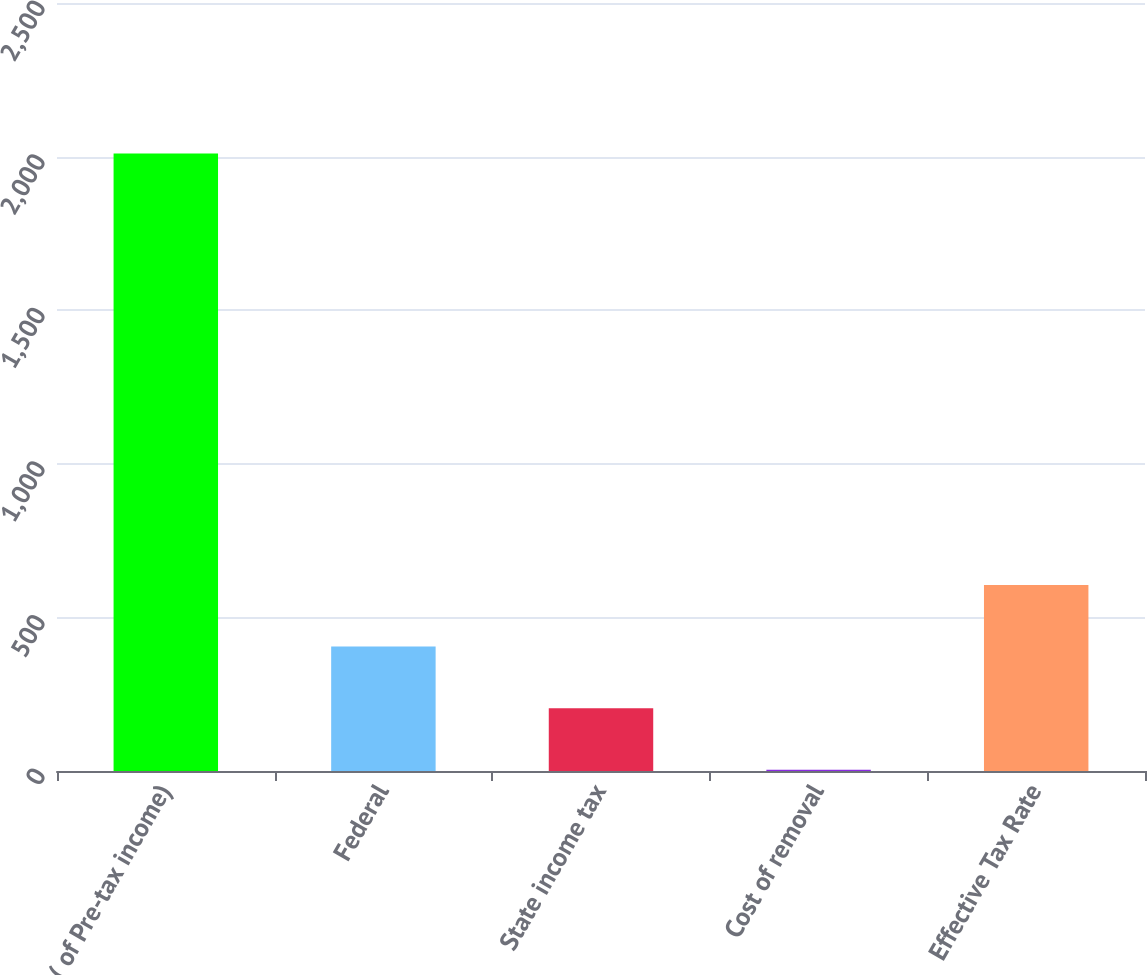Convert chart to OTSL. <chart><loc_0><loc_0><loc_500><loc_500><bar_chart><fcel>( of Pre-tax income)<fcel>Federal<fcel>State income tax<fcel>Cost of removal<fcel>Effective Tax Rate<nl><fcel>2010<fcel>405.2<fcel>204.6<fcel>4<fcel>605.8<nl></chart> 